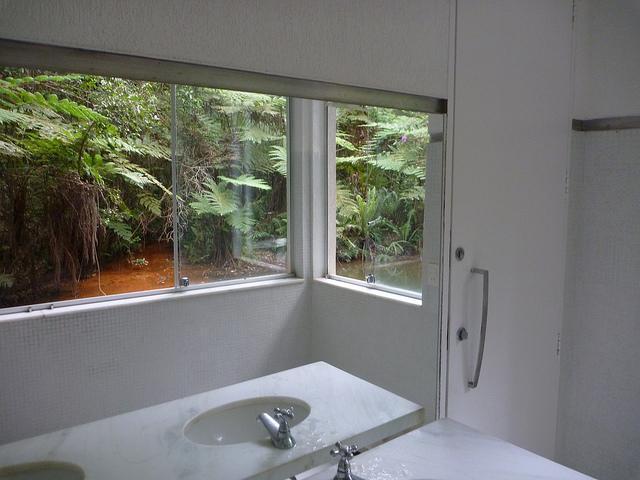How many windows are in the room?
Give a very brief answer. 2. How many sinks are in the picture?
Give a very brief answer. 1. 